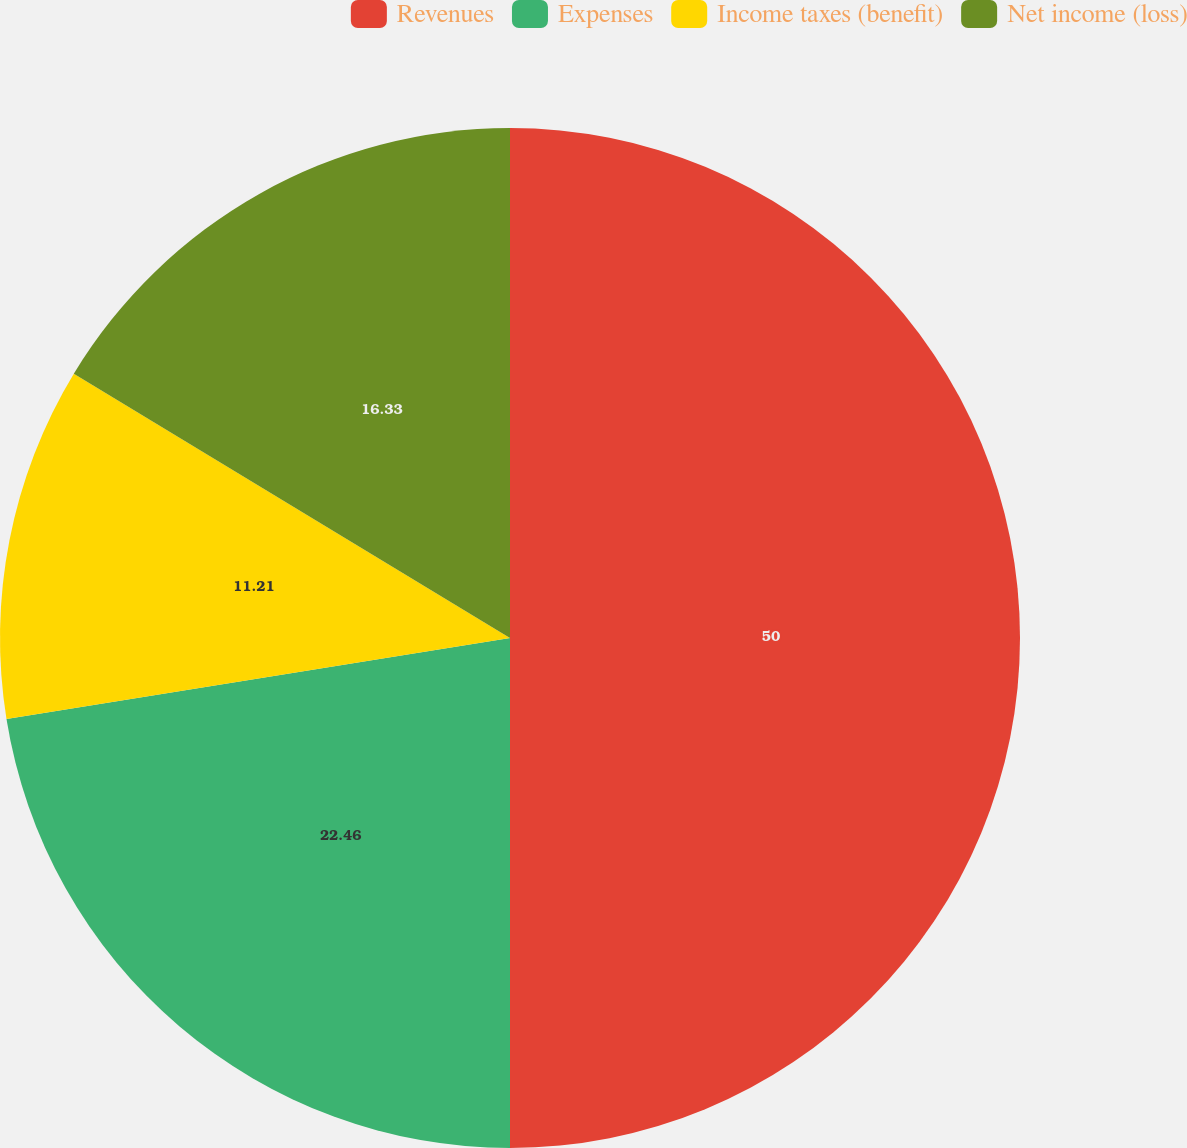Convert chart to OTSL. <chart><loc_0><loc_0><loc_500><loc_500><pie_chart><fcel>Revenues<fcel>Expenses<fcel>Income taxes (benefit)<fcel>Net income (loss)<nl><fcel>50.0%<fcel>22.46%<fcel>11.21%<fcel>16.33%<nl></chart> 